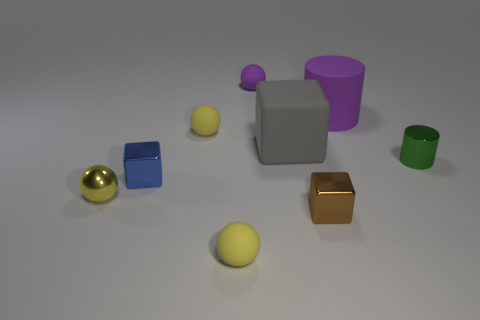How many yellow spheres must be subtracted to get 1 yellow spheres? 2 Subtract all gray cylinders. How many yellow balls are left? 3 Add 1 yellow things. How many objects exist? 10 Subtract all cylinders. How many objects are left? 7 Add 8 yellow rubber spheres. How many yellow rubber spheres are left? 10 Add 3 gray objects. How many gray objects exist? 4 Subtract 0 red cubes. How many objects are left? 9 Subtract all red matte cylinders. Subtract all small yellow matte spheres. How many objects are left? 7 